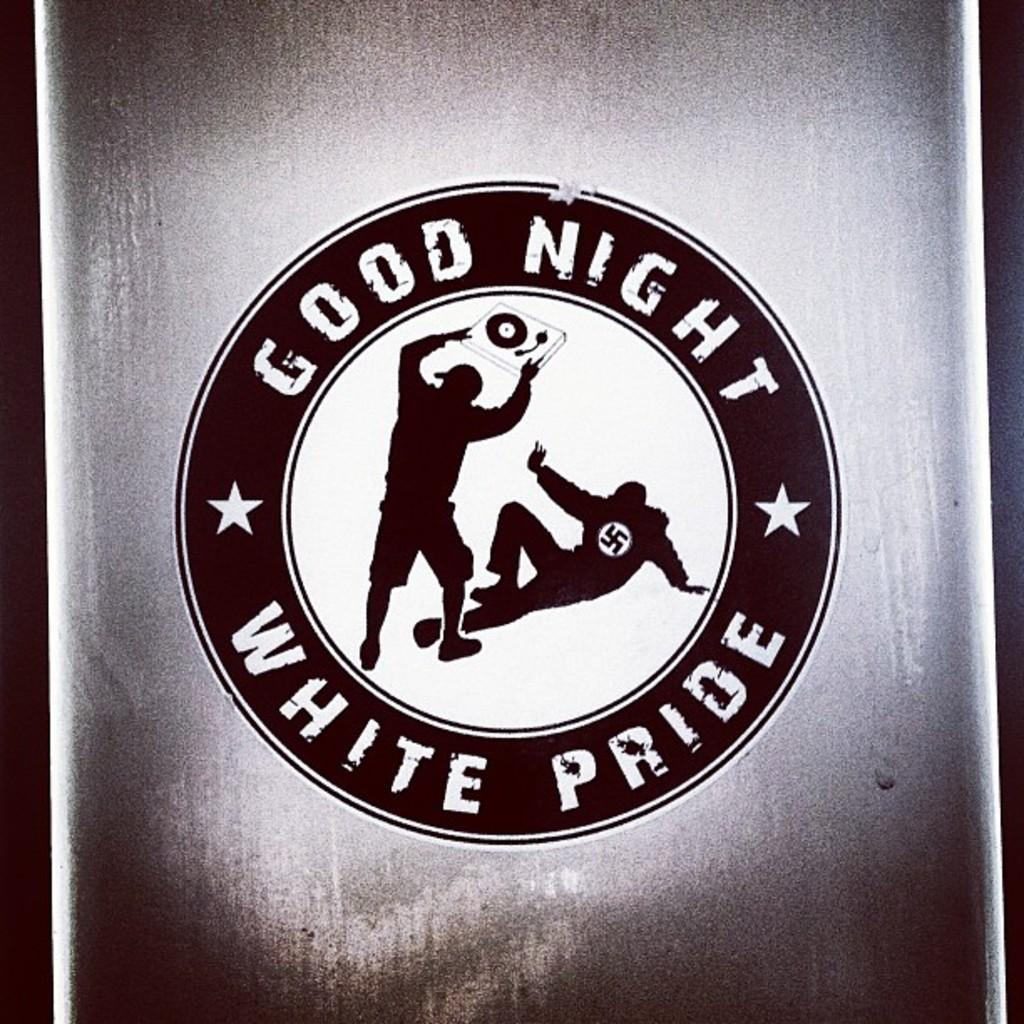<image>
Render a clear and concise summary of the photo. A black,while, and gray logo displaying a man on the ground with another man attacking him with the words Good Night White Pride around them 